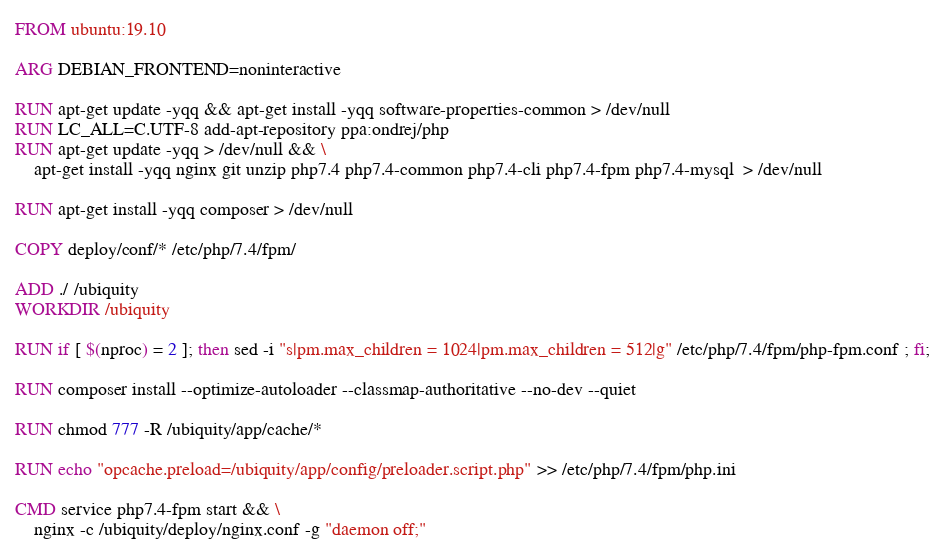Convert code to text. <code><loc_0><loc_0><loc_500><loc_500><_Dockerfile_>FROM ubuntu:19.10

ARG DEBIAN_FRONTEND=noninteractive

RUN apt-get update -yqq && apt-get install -yqq software-properties-common > /dev/null
RUN LC_ALL=C.UTF-8 add-apt-repository ppa:ondrej/php
RUN apt-get update -yqq > /dev/null && \
    apt-get install -yqq nginx git unzip php7.4 php7.4-common php7.4-cli php7.4-fpm php7.4-mysql  > /dev/null

RUN apt-get install -yqq composer > /dev/null

COPY deploy/conf/* /etc/php/7.4/fpm/

ADD ./ /ubiquity
WORKDIR /ubiquity

RUN if [ $(nproc) = 2 ]; then sed -i "s|pm.max_children = 1024|pm.max_children = 512|g" /etc/php/7.4/fpm/php-fpm.conf ; fi;

RUN composer install --optimize-autoloader --classmap-authoritative --no-dev --quiet

RUN chmod 777 -R /ubiquity/app/cache/*

RUN echo "opcache.preload=/ubiquity/app/config/preloader.script.php" >> /etc/php/7.4/fpm/php.ini

CMD service php7.4-fpm start && \
    nginx -c /ubiquity/deploy/nginx.conf -g "daemon off;"
</code> 